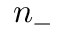Convert formula to latex. <formula><loc_0><loc_0><loc_500><loc_500>n _ { - }</formula> 